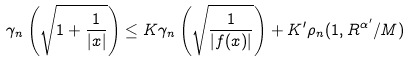Convert formula to latex. <formula><loc_0><loc_0><loc_500><loc_500>\gamma _ { n } \left ( \sqrt { 1 + \frac { 1 } { | x | } } \right ) \leq K \gamma _ { n } \left ( \sqrt { \frac { 1 } { | f ( x ) | } } \right ) + K ^ { \prime } \rho _ { n } ( 1 , R ^ { \alpha ^ { \prime } } / M )</formula> 